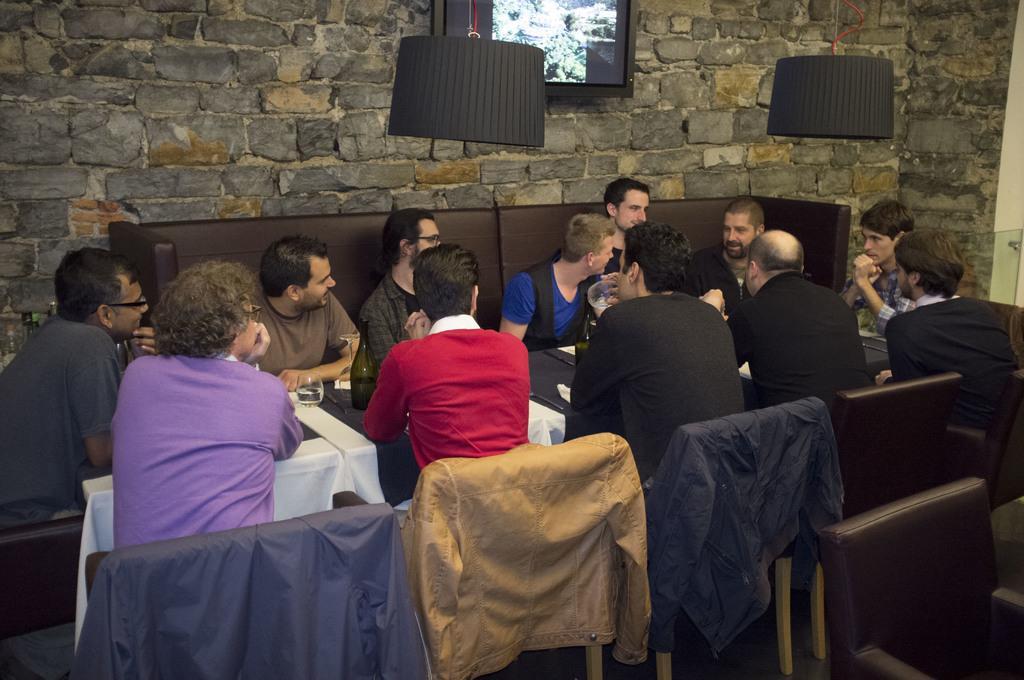How would you summarize this image in a sentence or two? As we can see in the image there are group of people sitting on chairs. In front of them there is a table. On table there is a bottle and on the top there is a screen. 